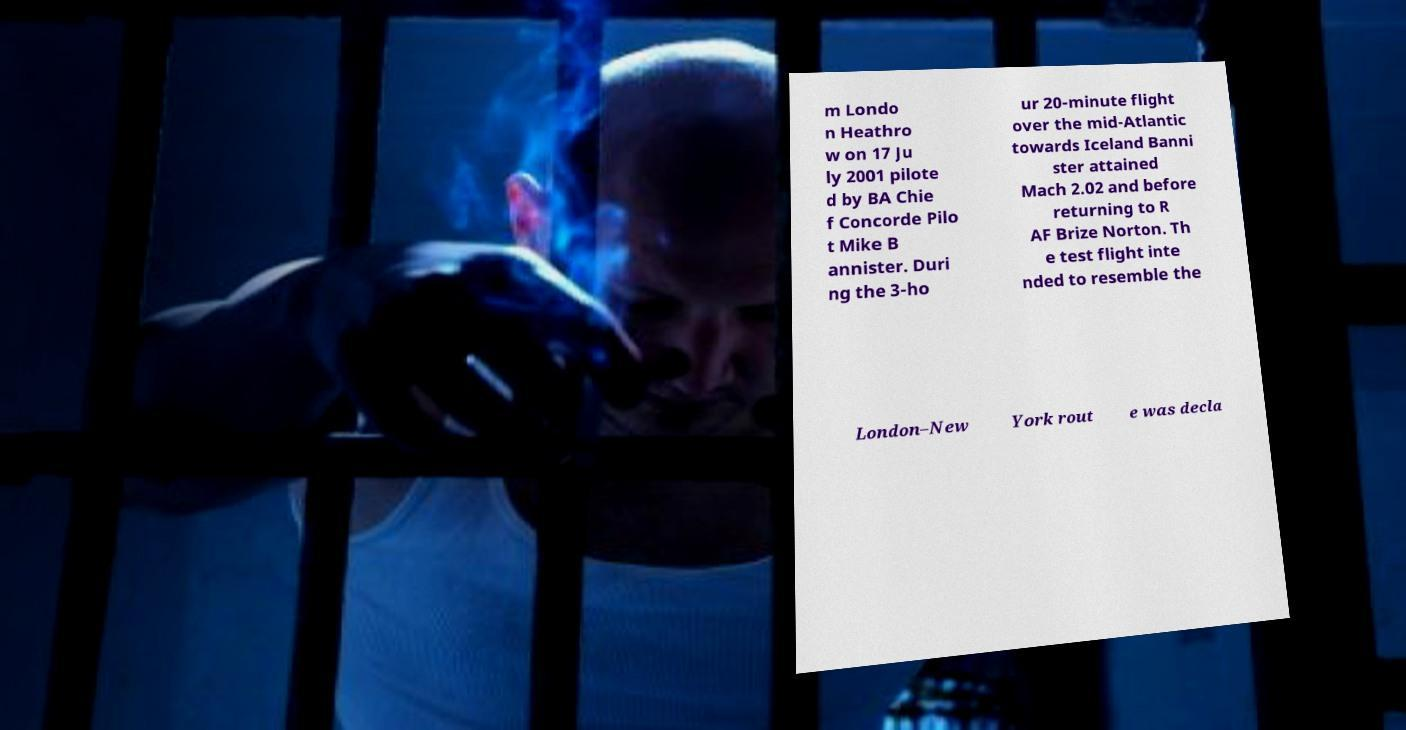Can you accurately transcribe the text from the provided image for me? m Londo n Heathro w on 17 Ju ly 2001 pilote d by BA Chie f Concorde Pilo t Mike B annister. Duri ng the 3-ho ur 20-minute flight over the mid-Atlantic towards Iceland Banni ster attained Mach 2.02 and before returning to R AF Brize Norton. Th e test flight inte nded to resemble the London–New York rout e was decla 